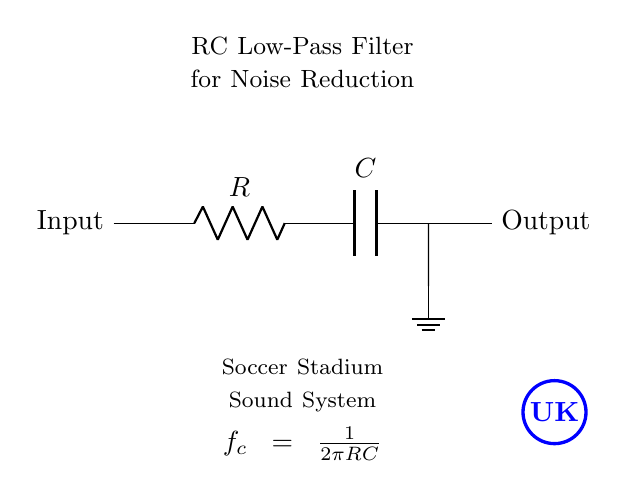What type of filter is shown in the circuit? The circuit is labeled as an RC Low-Pass Filter, which allows low-frequency signals to pass through while attenuating high-frequency signals.
Answer: RC Low-Pass Filter What are the components used in the circuit? The circuit includes a resistor (R) and a capacitor (C), which are the essential components for forming a low-pass filter.
Answer: Resistor and Capacitor What is the function of the ground in this circuit? The ground serves as the reference point for the circuit, completing the circuit and providing a return path for current flow.
Answer: Reference point What is the cutoff frequency equation for this filter? The equation provided in the diagram is used to calculate the cutoff frequency of the filter, which is given as f_c = 1/(2πRC). It indicates how R and C determine the frequency response.
Answer: f_c = 1/(2πRC) How does increasing the resistance affect the cutoff frequency? Increasing the resistance R will lead to a decrease in the cutoff frequency f_c, meaning that the filter will allow fewer high-frequency signals to pass through, making the system more effective against noise. This is derived from the formula as f_c is inversely proportional to R.
Answer: Decreases cutoff frequency What type of noise is this filter designed to reduce? This RC low-pass filter is specifically designed to reduce high-frequency noise that may interfere with sound clarity in a soccer stadium sound system.
Answer: High-frequency noise What is the expected output relative to the input at the cutoff frequency? At the cutoff frequency, the output will be at approximately 70.7% of the maximum input level, indicating that the filter significantly attenuates the signal beyond this frequency.
Answer: Approximately 70.7% 